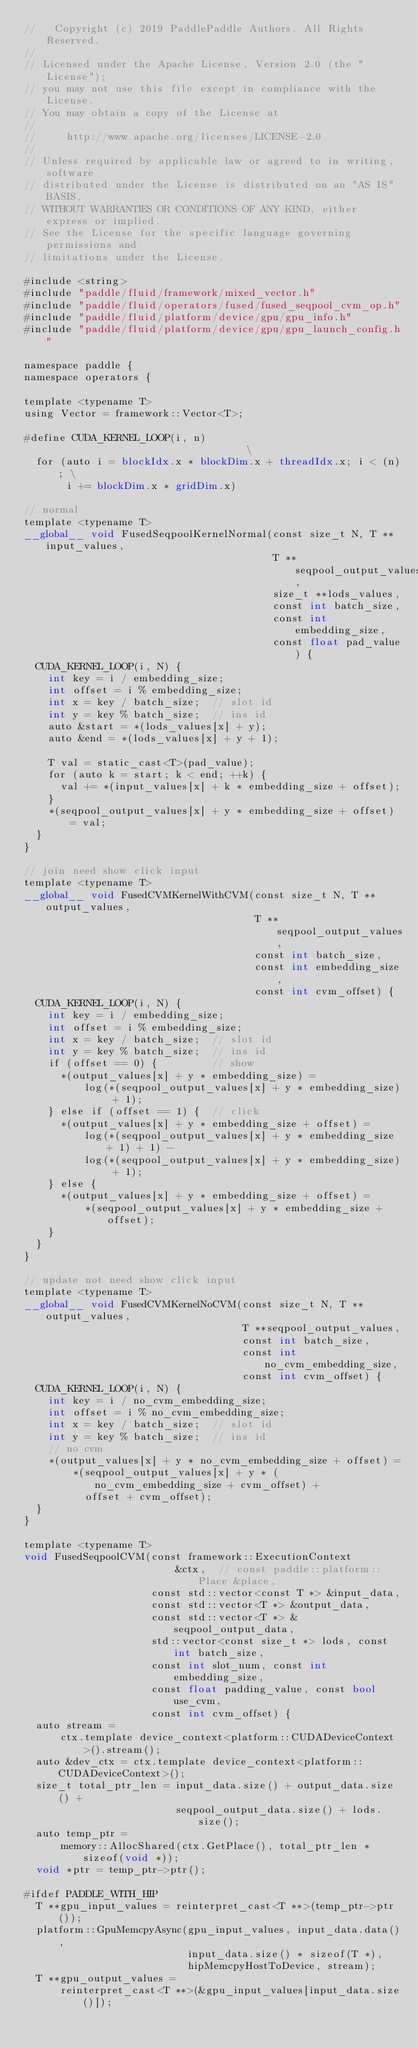Convert code to text. <code><loc_0><loc_0><loc_500><loc_500><_Cuda_>//   Copyright (c) 2019 PaddlePaddle Authors. All Rights Reserved.
//
// Licensed under the Apache License, Version 2.0 (the "License");
// you may not use this file except in compliance with the License.
// You may obtain a copy of the License at
//
//     http://www.apache.org/licenses/LICENSE-2.0
//
// Unless required by applicable law or agreed to in writing, software
// distributed under the License is distributed on an "AS IS" BASIS,
// WITHOUT WARRANTIES OR CONDITIONS OF ANY KIND, either express or implied.
// See the License for the specific language governing permissions and
// limitations under the License.

#include <string>
#include "paddle/fluid/framework/mixed_vector.h"
#include "paddle/fluid/operators/fused/fused_seqpool_cvm_op.h"
#include "paddle/fluid/platform/device/gpu/gpu_info.h"
#include "paddle/fluid/platform/device/gpu/gpu_launch_config.h"

namespace paddle {
namespace operators {

template <typename T>
using Vector = framework::Vector<T>;

#define CUDA_KERNEL_LOOP(i, n)                                  \
  for (auto i = blockIdx.x * blockDim.x + threadIdx.x; i < (n); \
       i += blockDim.x * gridDim.x)

// normal
template <typename T>
__global__ void FusedSeqpoolKernelNormal(const size_t N, T **input_values,
                                         T **seqpool_output_values,
                                         size_t **lods_values,
                                         const int batch_size,
                                         const int embedding_size,
                                         const float pad_value) {
  CUDA_KERNEL_LOOP(i, N) {
    int key = i / embedding_size;
    int offset = i % embedding_size;
    int x = key / batch_size;  // slot id
    int y = key % batch_size;  // ins id
    auto &start = *(lods_values[x] + y);
    auto &end = *(lods_values[x] + y + 1);

    T val = static_cast<T>(pad_value);
    for (auto k = start; k < end; ++k) {
      val += *(input_values[x] + k * embedding_size + offset);
    }
    *(seqpool_output_values[x] + y * embedding_size + offset) = val;
  }
}

// join need show click input
template <typename T>
__global__ void FusedCVMKernelWithCVM(const size_t N, T **output_values,
                                      T **seqpool_output_values,
                                      const int batch_size,
                                      const int embedding_size,
                                      const int cvm_offset) {
  CUDA_KERNEL_LOOP(i, N) {
    int key = i / embedding_size;
    int offset = i % embedding_size;
    int x = key / batch_size;  // slot id
    int y = key % batch_size;  // ins id
    if (offset == 0) {         // show
      *(output_values[x] + y * embedding_size) =
          log(*(seqpool_output_values[x] + y * embedding_size) + 1);
    } else if (offset == 1) {  // click
      *(output_values[x] + y * embedding_size + offset) =
          log(*(seqpool_output_values[x] + y * embedding_size + 1) + 1) -
          log(*(seqpool_output_values[x] + y * embedding_size) + 1);
    } else {
      *(output_values[x] + y * embedding_size + offset) =
          *(seqpool_output_values[x] + y * embedding_size + offset);
    }
  }
}

// update not need show click input
template <typename T>
__global__ void FusedCVMKernelNoCVM(const size_t N, T **output_values,
                                    T **seqpool_output_values,
                                    const int batch_size,
                                    const int no_cvm_embedding_size,
                                    const int cvm_offset) {
  CUDA_KERNEL_LOOP(i, N) {
    int key = i / no_cvm_embedding_size;
    int offset = i % no_cvm_embedding_size;
    int x = key / batch_size;  // slot id
    int y = key % batch_size;  // ins id
    // no cvm
    *(output_values[x] + y * no_cvm_embedding_size + offset) =
        *(seqpool_output_values[x] + y * (no_cvm_embedding_size + cvm_offset) +
          offset + cvm_offset);
  }
}

template <typename T>
void FusedSeqpoolCVM(const framework::ExecutionContext
                         &ctx,  // const paddle::platform::Place &place,
                     const std::vector<const T *> &input_data,
                     const std::vector<T *> &output_data,
                     const std::vector<T *> &seqpool_output_data,
                     std::vector<const size_t *> lods, const int batch_size,
                     const int slot_num, const int embedding_size,
                     const float padding_value, const bool use_cvm,
                     const int cvm_offset) {
  auto stream =
      ctx.template device_context<platform::CUDADeviceContext>().stream();
  auto &dev_ctx = ctx.template device_context<platform::CUDADeviceContext>();
  size_t total_ptr_len = input_data.size() + output_data.size() +
                         seqpool_output_data.size() + lods.size();
  auto temp_ptr =
      memory::AllocShared(ctx.GetPlace(), total_ptr_len * sizeof(void *));
  void *ptr = temp_ptr->ptr();

#ifdef PADDLE_WITH_HIP
  T **gpu_input_values = reinterpret_cast<T **>(temp_ptr->ptr());
  platform::GpuMemcpyAsync(gpu_input_values, input_data.data(),
                           input_data.size() * sizeof(T *),
                           hipMemcpyHostToDevice, stream);
  T **gpu_output_values =
      reinterpret_cast<T **>(&gpu_input_values[input_data.size()]);</code> 